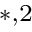Convert formula to latex. <formula><loc_0><loc_0><loc_500><loc_500>^ { * , 2 }</formula> 